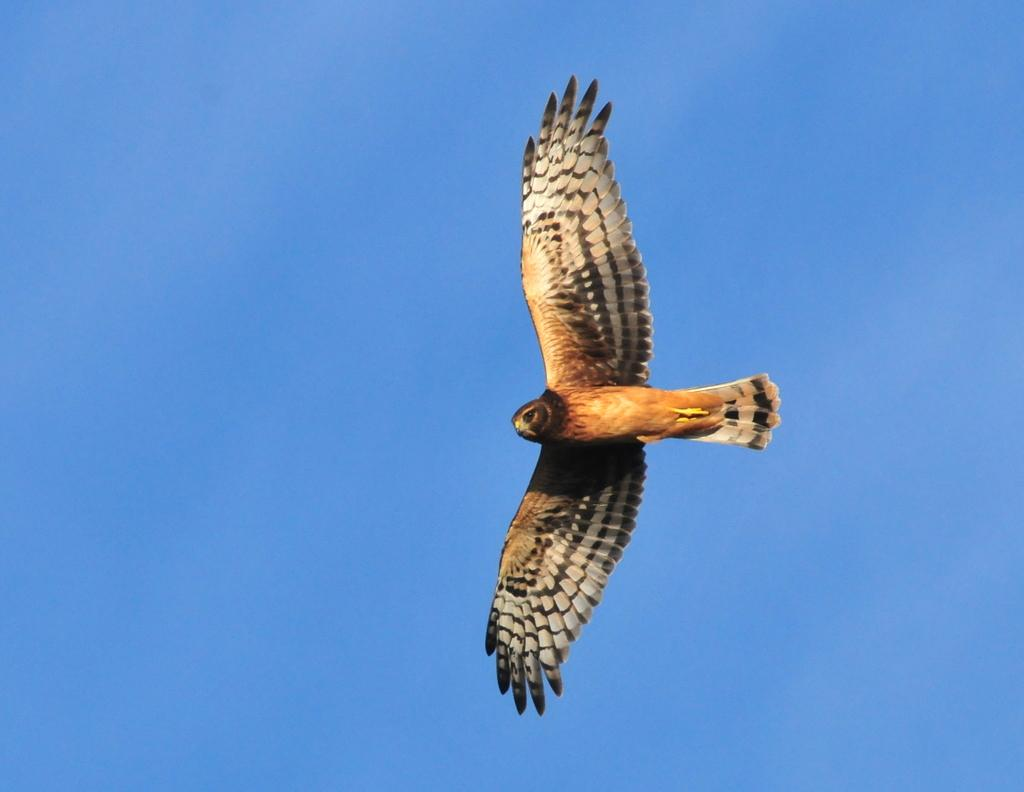What type of animal can be seen in the image? There is a bird in the image. What is the bird doing in the image? The bird is flying in the sky. How does the bird contribute to the quietness of the image? The bird does not contribute to the quietness of the image, as it is flying and making noise from its wings flapping. 